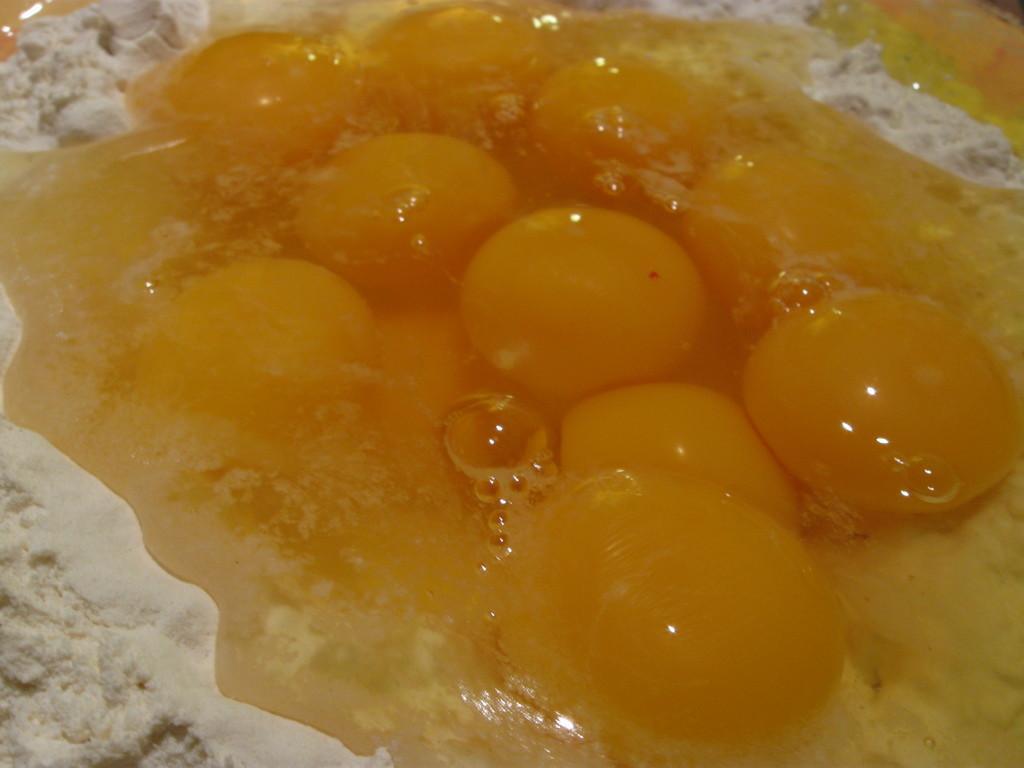How would you summarize this image in a sentence or two? In this image I can see the cream colored flour and the yellow colored liquid on the flour. 